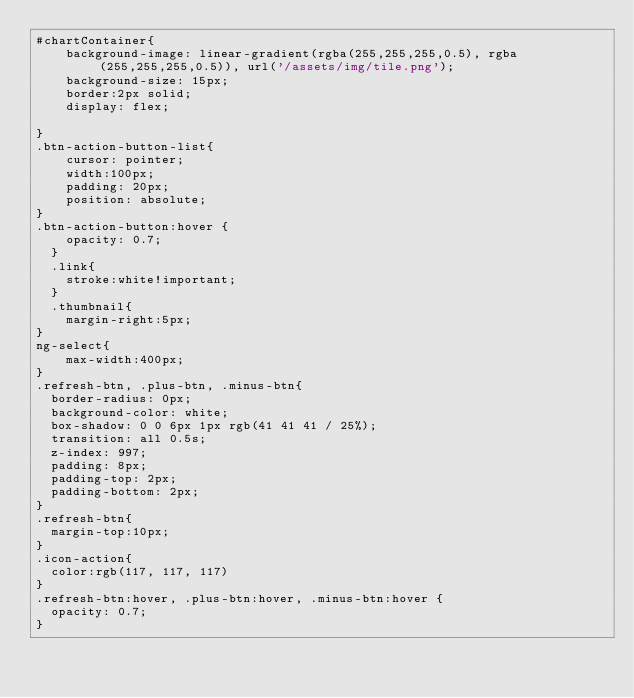<code> <loc_0><loc_0><loc_500><loc_500><_CSS_>#chartContainer{
    background-image: linear-gradient(rgba(255,255,255,0.5), rgba(255,255,255,0.5)), url('/assets/img/tile.png');
    background-size: 15px;
    border:2px solid;
    display: flex;
    
}
.btn-action-button-list{
    cursor: pointer;
    width:100px;
    padding: 20px;
    position: absolute;
}
.btn-action-button:hover {
    opacity: 0.7;
  }
  .link{
    stroke:white!important;
  }
  .thumbnail{
    margin-right:5px;
}
ng-select{
    max-width:400px;
}
.refresh-btn, .plus-btn, .minus-btn{
  border-radius: 0px;
  background-color: white;
  box-shadow: 0 0 6px 1px rgb(41 41 41 / 25%);
  transition: all 0.5s;
  z-index: 997;
  padding: 8px;
  padding-top: 2px;
  padding-bottom: 2px;
}
.refresh-btn{
  margin-top:10px;
}
.icon-action{
  color:rgb(117, 117, 117)
}
.refresh-btn:hover, .plus-btn:hover, .minus-btn:hover {
  opacity: 0.7;
}</code> 